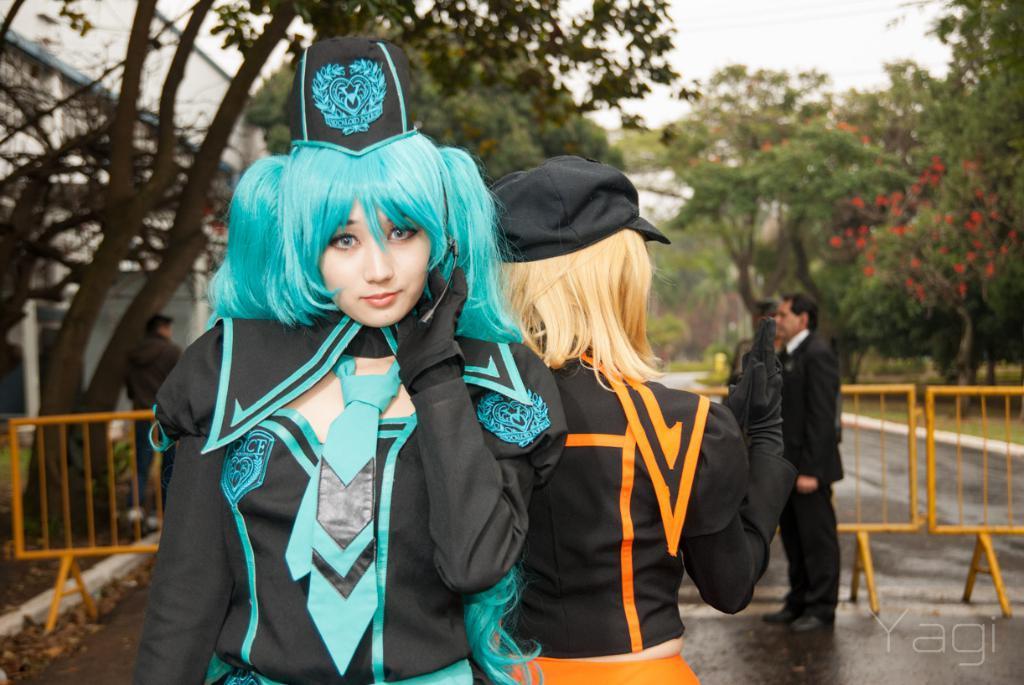Please provide a concise description of this image. In this picture I can observe two women. One of them is wearing black and blue color dress and I can observe blue color hair on her head and the other woman is wearing black and orange color dress. There is black color cap on her head. On the right side there is man standing, wearing black color coat. I can observe yellow color railing on the road. In the background there are trees and a sky. 